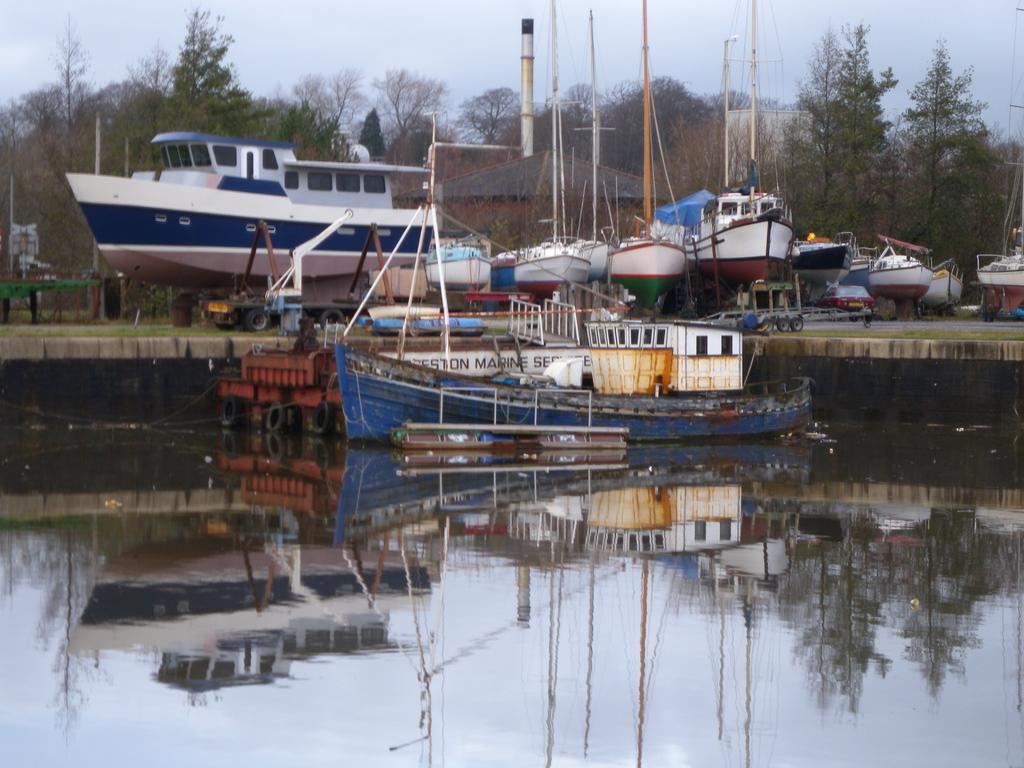Describe this image in one or two sentences. In the picture I can see the ships is on the water surface. In the background, I can see ships and group of trees. 